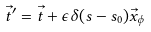Convert formula to latex. <formula><loc_0><loc_0><loc_500><loc_500>\vec { t } ^ { \prime } = \vec { t } + \epsilon \delta ( s - s _ { 0 } ) \vec { x } _ { \phi }</formula> 